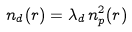<formula> <loc_0><loc_0><loc_500><loc_500>n _ { d } ( r ) = \lambda _ { d } \, n _ { p } ^ { 2 } ( r )</formula> 